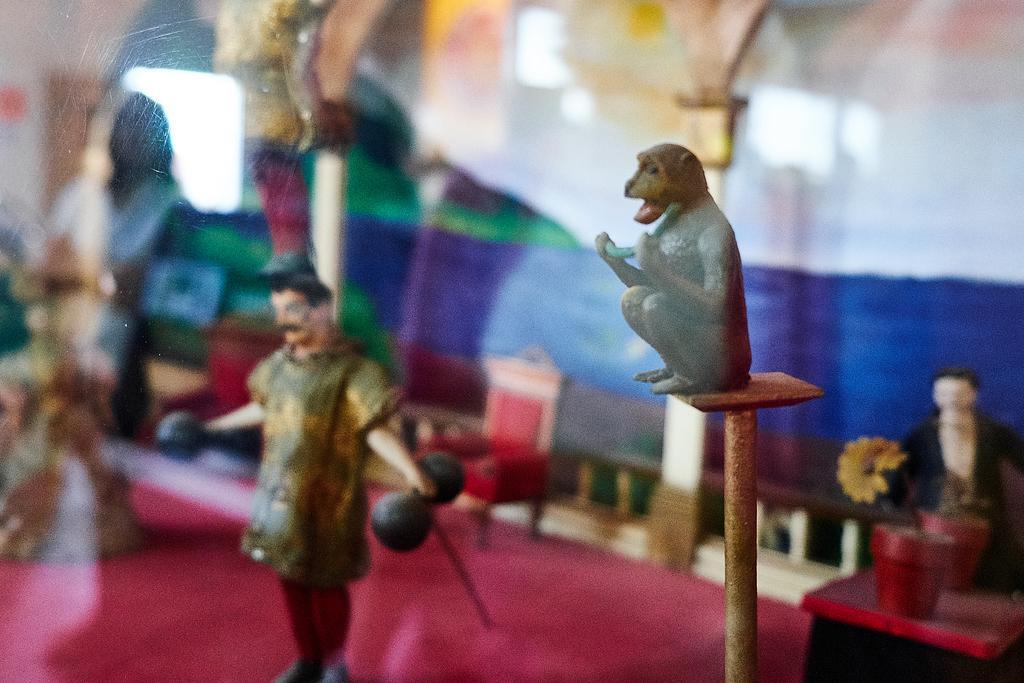How would you summarize this image in a sentence or two? These are the toys. I can see a monkey, person, chair, flower pots and flower. This looks like a glass door. 